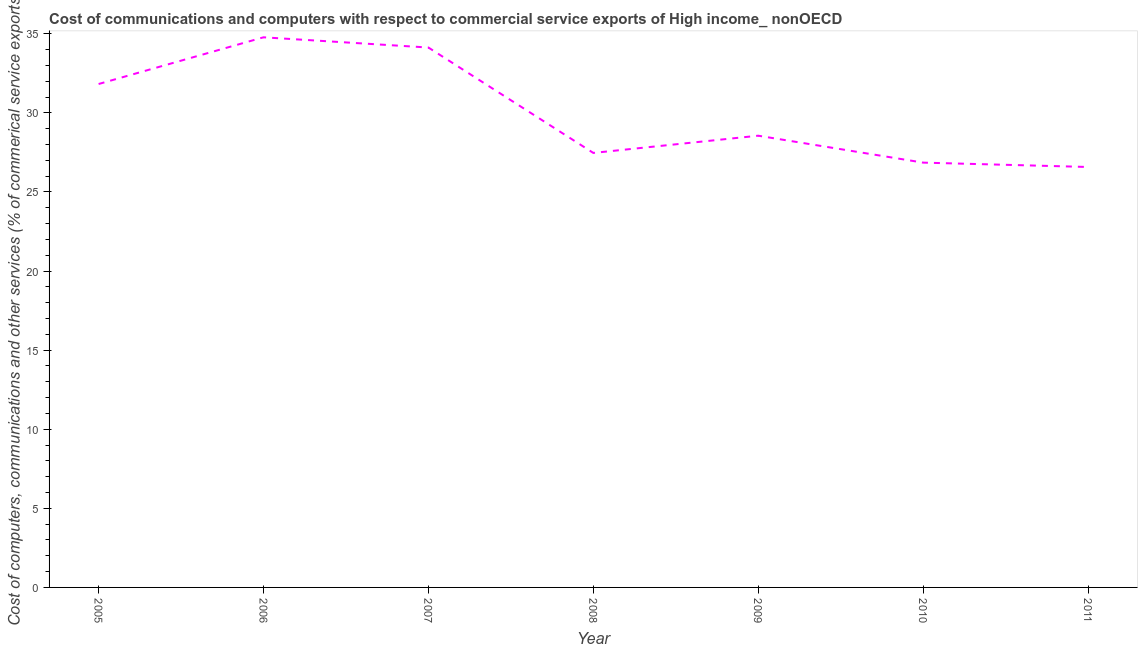What is the  computer and other services in 2008?
Provide a succinct answer. 27.47. Across all years, what is the maximum cost of communications?
Make the answer very short. 34.78. Across all years, what is the minimum cost of communications?
Offer a very short reply. 26.58. In which year was the cost of communications minimum?
Ensure brevity in your answer.  2011. What is the sum of the  computer and other services?
Ensure brevity in your answer.  210.19. What is the difference between the  computer and other services in 2005 and 2011?
Provide a succinct answer. 5.25. What is the average  computer and other services per year?
Give a very brief answer. 30.03. What is the median cost of communications?
Provide a short and direct response. 28.56. What is the ratio of the cost of communications in 2006 to that in 2007?
Give a very brief answer. 1.02. Is the  computer and other services in 2008 less than that in 2009?
Offer a very short reply. Yes. Is the difference between the cost of communications in 2007 and 2008 greater than the difference between any two years?
Keep it short and to the point. No. What is the difference between the highest and the second highest  computer and other services?
Keep it short and to the point. 0.65. What is the difference between the highest and the lowest  computer and other services?
Offer a terse response. 8.2. In how many years, is the  computer and other services greater than the average  computer and other services taken over all years?
Provide a succinct answer. 3. How many lines are there?
Your answer should be very brief. 1. How many years are there in the graph?
Provide a succinct answer. 7. What is the difference between two consecutive major ticks on the Y-axis?
Your response must be concise. 5. Are the values on the major ticks of Y-axis written in scientific E-notation?
Ensure brevity in your answer.  No. What is the title of the graph?
Ensure brevity in your answer.  Cost of communications and computers with respect to commercial service exports of High income_ nonOECD. What is the label or title of the X-axis?
Give a very brief answer. Year. What is the label or title of the Y-axis?
Your response must be concise. Cost of computers, communications and other services (% of commerical service exports). What is the Cost of computers, communications and other services (% of commerical service exports) in 2005?
Your answer should be compact. 31.82. What is the Cost of computers, communications and other services (% of commerical service exports) in 2006?
Your answer should be compact. 34.78. What is the Cost of computers, communications and other services (% of commerical service exports) of 2007?
Provide a succinct answer. 34.13. What is the Cost of computers, communications and other services (% of commerical service exports) in 2008?
Keep it short and to the point. 27.47. What is the Cost of computers, communications and other services (% of commerical service exports) in 2009?
Provide a short and direct response. 28.56. What is the Cost of computers, communications and other services (% of commerical service exports) of 2010?
Your answer should be very brief. 26.85. What is the Cost of computers, communications and other services (% of commerical service exports) of 2011?
Offer a very short reply. 26.58. What is the difference between the Cost of computers, communications and other services (% of commerical service exports) in 2005 and 2006?
Ensure brevity in your answer.  -2.95. What is the difference between the Cost of computers, communications and other services (% of commerical service exports) in 2005 and 2007?
Your answer should be compact. -2.31. What is the difference between the Cost of computers, communications and other services (% of commerical service exports) in 2005 and 2008?
Offer a very short reply. 4.36. What is the difference between the Cost of computers, communications and other services (% of commerical service exports) in 2005 and 2009?
Keep it short and to the point. 3.27. What is the difference between the Cost of computers, communications and other services (% of commerical service exports) in 2005 and 2010?
Give a very brief answer. 4.97. What is the difference between the Cost of computers, communications and other services (% of commerical service exports) in 2005 and 2011?
Ensure brevity in your answer.  5.25. What is the difference between the Cost of computers, communications and other services (% of commerical service exports) in 2006 and 2007?
Ensure brevity in your answer.  0.65. What is the difference between the Cost of computers, communications and other services (% of commerical service exports) in 2006 and 2008?
Offer a very short reply. 7.31. What is the difference between the Cost of computers, communications and other services (% of commerical service exports) in 2006 and 2009?
Keep it short and to the point. 6.22. What is the difference between the Cost of computers, communications and other services (% of commerical service exports) in 2006 and 2010?
Your answer should be compact. 7.92. What is the difference between the Cost of computers, communications and other services (% of commerical service exports) in 2006 and 2011?
Your answer should be compact. 8.2. What is the difference between the Cost of computers, communications and other services (% of commerical service exports) in 2007 and 2008?
Ensure brevity in your answer.  6.66. What is the difference between the Cost of computers, communications and other services (% of commerical service exports) in 2007 and 2009?
Provide a short and direct response. 5.57. What is the difference between the Cost of computers, communications and other services (% of commerical service exports) in 2007 and 2010?
Ensure brevity in your answer.  7.28. What is the difference between the Cost of computers, communications and other services (% of commerical service exports) in 2007 and 2011?
Offer a very short reply. 7.55. What is the difference between the Cost of computers, communications and other services (% of commerical service exports) in 2008 and 2009?
Ensure brevity in your answer.  -1.09. What is the difference between the Cost of computers, communications and other services (% of commerical service exports) in 2008 and 2010?
Provide a succinct answer. 0.61. What is the difference between the Cost of computers, communications and other services (% of commerical service exports) in 2008 and 2011?
Your answer should be very brief. 0.89. What is the difference between the Cost of computers, communications and other services (% of commerical service exports) in 2009 and 2010?
Offer a terse response. 1.7. What is the difference between the Cost of computers, communications and other services (% of commerical service exports) in 2009 and 2011?
Provide a succinct answer. 1.98. What is the difference between the Cost of computers, communications and other services (% of commerical service exports) in 2010 and 2011?
Offer a terse response. 0.28. What is the ratio of the Cost of computers, communications and other services (% of commerical service exports) in 2005 to that in 2006?
Offer a terse response. 0.92. What is the ratio of the Cost of computers, communications and other services (% of commerical service exports) in 2005 to that in 2007?
Offer a terse response. 0.93. What is the ratio of the Cost of computers, communications and other services (% of commerical service exports) in 2005 to that in 2008?
Keep it short and to the point. 1.16. What is the ratio of the Cost of computers, communications and other services (% of commerical service exports) in 2005 to that in 2009?
Your answer should be compact. 1.11. What is the ratio of the Cost of computers, communications and other services (% of commerical service exports) in 2005 to that in 2010?
Keep it short and to the point. 1.19. What is the ratio of the Cost of computers, communications and other services (% of commerical service exports) in 2005 to that in 2011?
Offer a terse response. 1.2. What is the ratio of the Cost of computers, communications and other services (% of commerical service exports) in 2006 to that in 2008?
Your answer should be very brief. 1.27. What is the ratio of the Cost of computers, communications and other services (% of commerical service exports) in 2006 to that in 2009?
Make the answer very short. 1.22. What is the ratio of the Cost of computers, communications and other services (% of commerical service exports) in 2006 to that in 2010?
Offer a terse response. 1.29. What is the ratio of the Cost of computers, communications and other services (% of commerical service exports) in 2006 to that in 2011?
Give a very brief answer. 1.31. What is the ratio of the Cost of computers, communications and other services (% of commerical service exports) in 2007 to that in 2008?
Ensure brevity in your answer.  1.24. What is the ratio of the Cost of computers, communications and other services (% of commerical service exports) in 2007 to that in 2009?
Offer a very short reply. 1.2. What is the ratio of the Cost of computers, communications and other services (% of commerical service exports) in 2007 to that in 2010?
Your answer should be compact. 1.27. What is the ratio of the Cost of computers, communications and other services (% of commerical service exports) in 2007 to that in 2011?
Offer a terse response. 1.28. What is the ratio of the Cost of computers, communications and other services (% of commerical service exports) in 2008 to that in 2011?
Your answer should be compact. 1.03. What is the ratio of the Cost of computers, communications and other services (% of commerical service exports) in 2009 to that in 2010?
Your response must be concise. 1.06. What is the ratio of the Cost of computers, communications and other services (% of commerical service exports) in 2009 to that in 2011?
Your response must be concise. 1.07. What is the ratio of the Cost of computers, communications and other services (% of commerical service exports) in 2010 to that in 2011?
Ensure brevity in your answer.  1.01. 